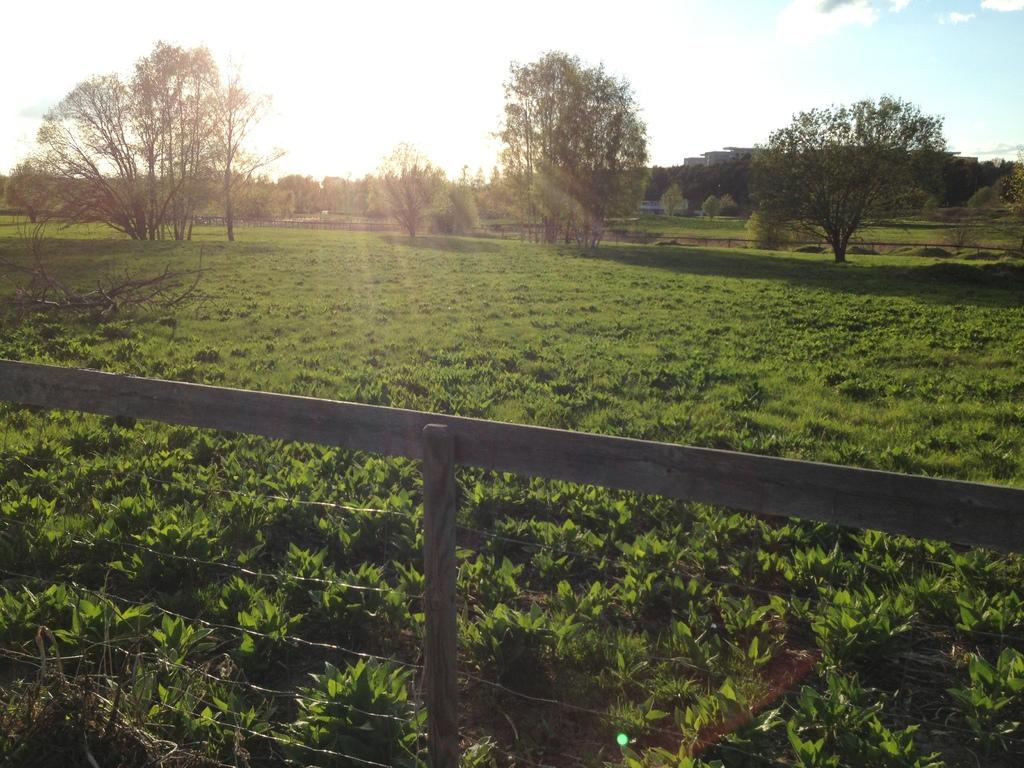What type of vegetation is present on the ground in the image? There are plants and grass on the ground in the image. What can be seen in the foreground of the image? There is fencing in the foreground of the image. What is visible in the background of the image? There are trees and buildings in the background of the image. What is visible at the top of the image? The sky is visible at the top of the image. Can you tell me how many basketballs are visible in the image? There are no basketballs present in the image. What type of alarm is set up near the fencing in the image? There is no alarm present in the image; it features fencing, plants, grass, trees, buildings, and the sky. 